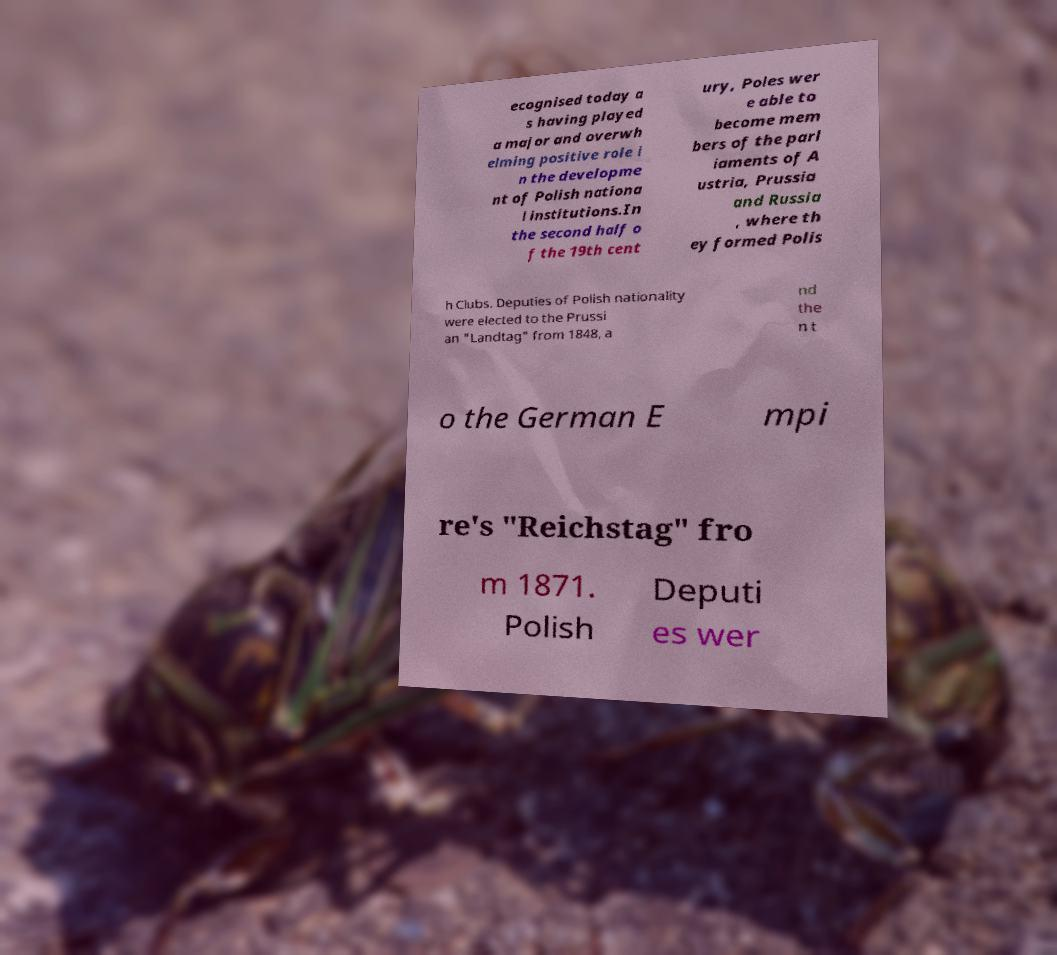I need the written content from this picture converted into text. Can you do that? ecognised today a s having played a major and overwh elming positive role i n the developme nt of Polish nationa l institutions.In the second half o f the 19th cent ury, Poles wer e able to become mem bers of the parl iaments of A ustria, Prussia and Russia , where th ey formed Polis h Clubs. Deputies of Polish nationality were elected to the Prussi an "Landtag" from 1848, a nd the n t o the German E mpi re's "Reichstag" fro m 1871. Polish Deputi es wer 